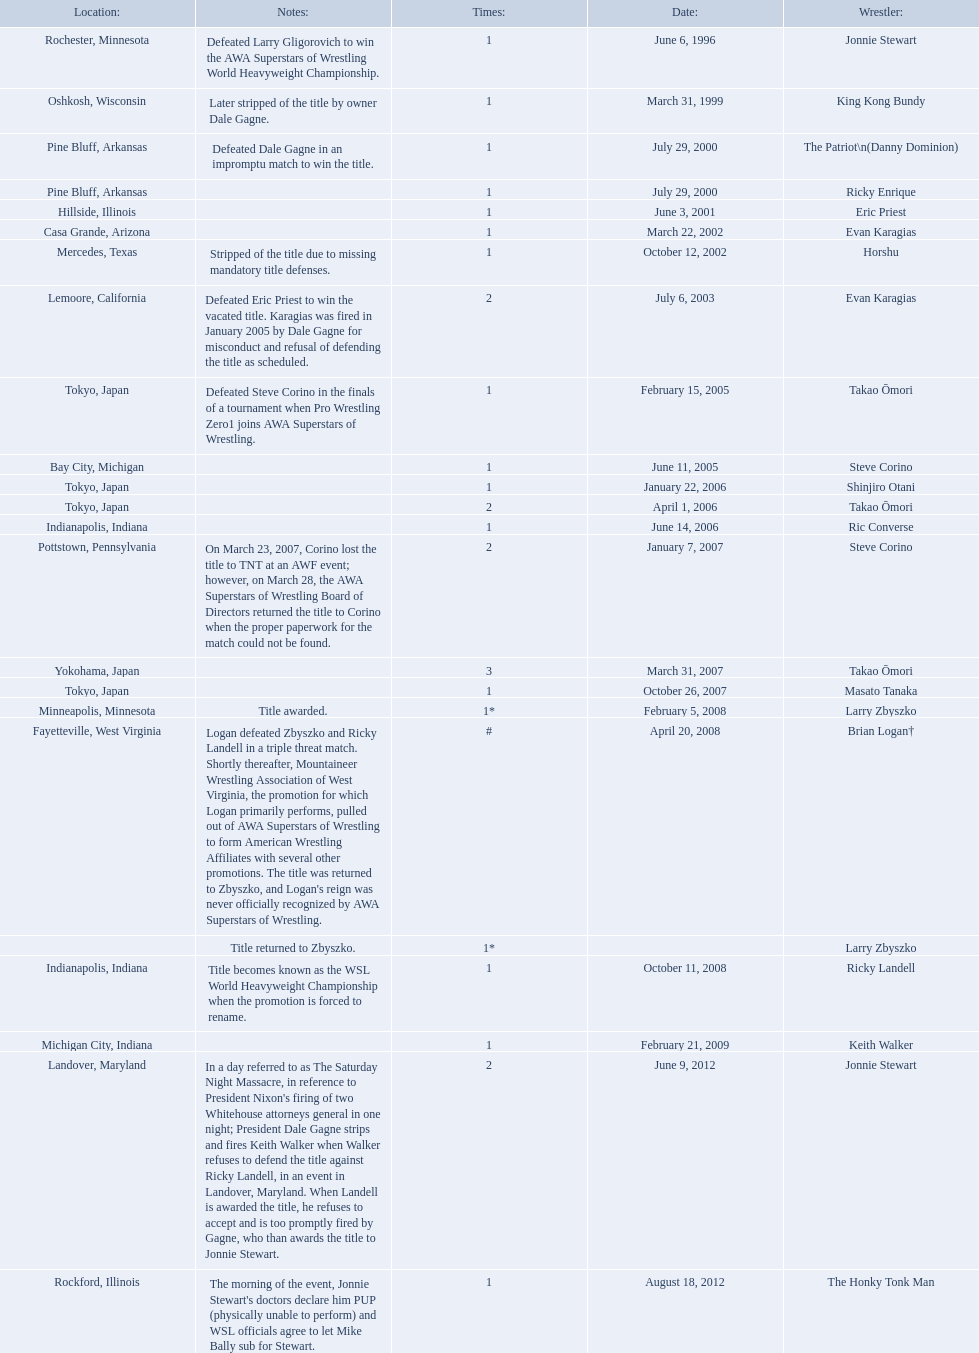Who are the wrestlers? Jonnie Stewart, Rochester, Minnesota, King Kong Bundy, Oshkosh, Wisconsin, The Patriot\n(Danny Dominion), Pine Bluff, Arkansas, Ricky Enrique, Pine Bluff, Arkansas, Eric Priest, Hillside, Illinois, Evan Karagias, Casa Grande, Arizona, Horshu, Mercedes, Texas, Evan Karagias, Lemoore, California, Takao Ōmori, Tokyo, Japan, Steve Corino, Bay City, Michigan, Shinjiro Otani, Tokyo, Japan, Takao Ōmori, Tokyo, Japan, Ric Converse, Indianapolis, Indiana, Steve Corino, Pottstown, Pennsylvania, Takao Ōmori, Yokohama, Japan, Masato Tanaka, Tokyo, Japan, Larry Zbyszko, Minneapolis, Minnesota, Brian Logan†, Fayetteville, West Virginia, Larry Zbyszko, , Ricky Landell, Indianapolis, Indiana, Keith Walker, Michigan City, Indiana, Jonnie Stewart, Landover, Maryland, The Honky Tonk Man, Rockford, Illinois. Who was from texas? Horshu, Mercedes, Texas. Who is he? Horshu. 